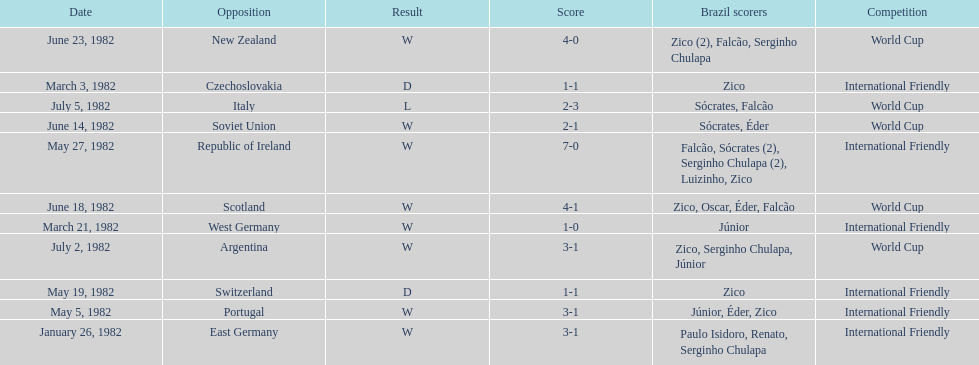What are the dates? January 26, 1982, March 3, 1982, March 21, 1982, May 5, 1982, May 19, 1982, May 27, 1982, June 14, 1982, June 18, 1982, June 23, 1982, July 2, 1982, July 5, 1982. And which date is listed first? January 26, 1982. 